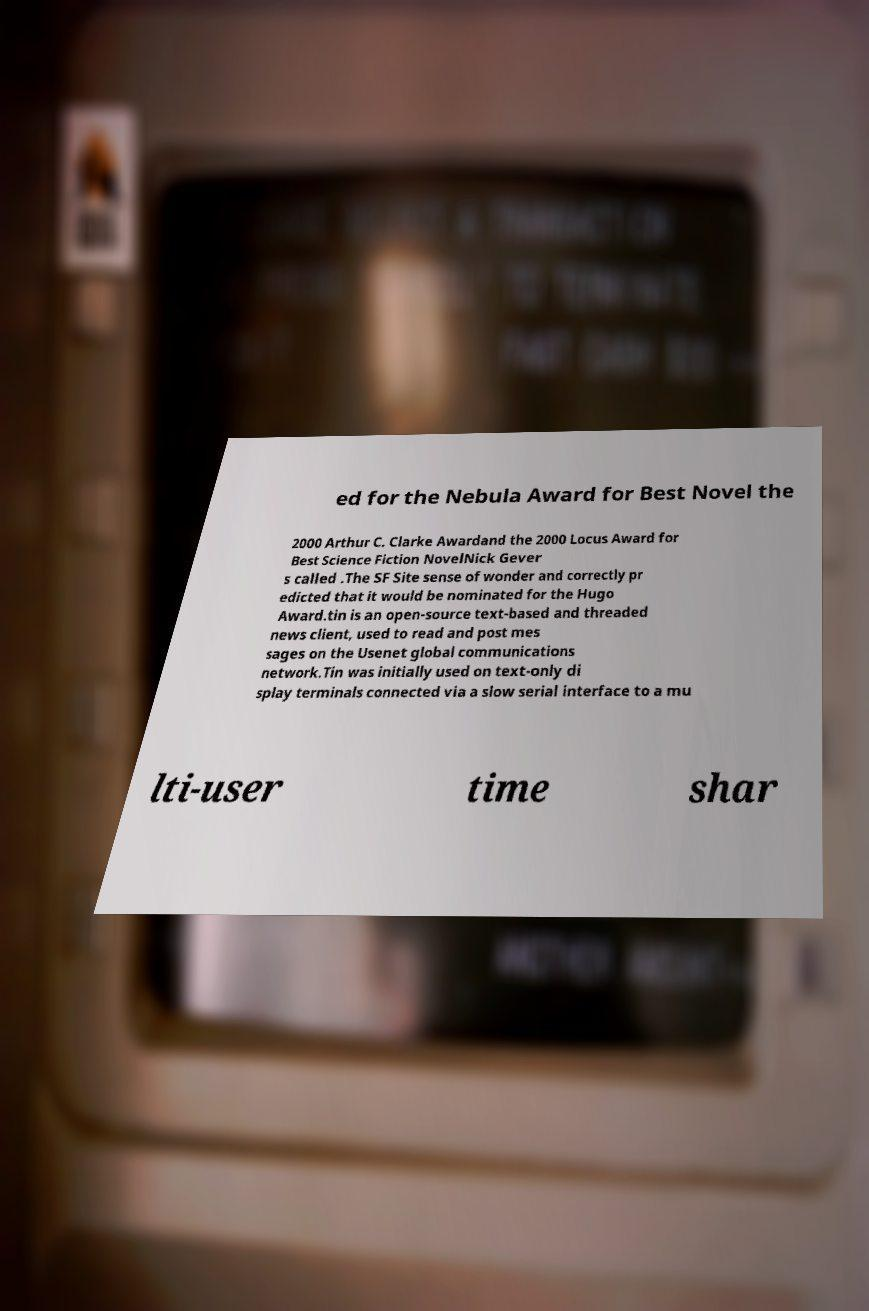Could you extract and type out the text from this image? ed for the Nebula Award for Best Novel the 2000 Arthur C. Clarke Awardand the 2000 Locus Award for Best Science Fiction NovelNick Gever s called .The SF Site sense of wonder and correctly pr edicted that it would be nominated for the Hugo Award.tin is an open-source text-based and threaded news client, used to read and post mes sages on the Usenet global communications network.Tin was initially used on text-only di splay terminals connected via a slow serial interface to a mu lti-user time shar 